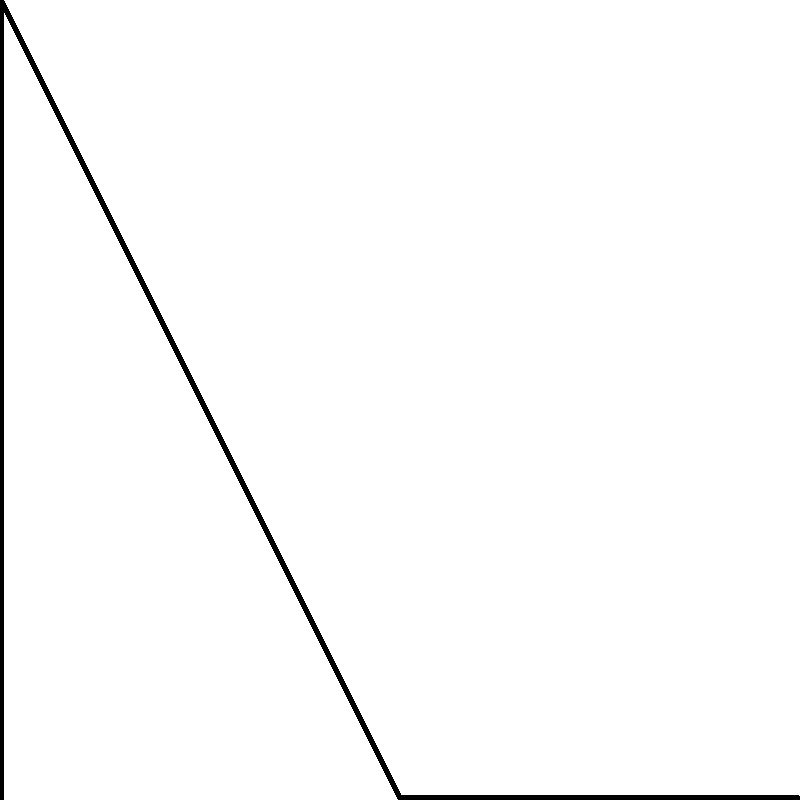Given the stick figure diagram representing a simplified human leg during gait, with joint angles $\theta_1$ and $\theta_2$ as shown, prove that the total vertical displacement of the ankle joint can be expressed as a function of these angles and the lengths of the thigh and shank segments. Assume the hip joint is fixed. Let's approach this proof step-by-step:

1) Define variables:
   Let $l_1$ be the length of the thigh segment (hip to knee)
   Let $l_2$ be the length of the shank segment (knee to ankle)

2) Express the coordinates of the knee joint (B) relative to the hip (A):
   $x_B = l_1 \sin(\theta_1)$
   $y_B = -l_1 \cos(\theta_1)$

3) Express the coordinates of the ankle joint (C) relative to the knee (B):
   $x_C = x_B + l_2 \sin(\theta_1 + \theta_2)$
   $y_C = y_B - l_2 \cos(\theta_1 + \theta_2)$

4) Substitute the expressions for $x_B$ and $y_B$:
   $x_C = l_1 \sin(\theta_1) + l_2 \sin(\theta_1 + \theta_2)$
   $y_C = -l_1 \cos(\theta_1) - l_2 \cos(\theta_1 + \theta_2)$

5) The vertical displacement of the ankle is given by $y_C$. Therefore:
   Vertical displacement = $-l_1 \cos(\theta_1) - l_2 \cos(\theta_1 + \theta_2)$

6) This expression is a function of $\theta_1$, $\theta_2$, $l_1$, and $l_2$, proving that the vertical displacement can be expressed as a function of the joint angles and segment lengths.
Answer: $-l_1 \cos(\theta_1) - l_2 \cos(\theta_1 + \theta_2)$ 